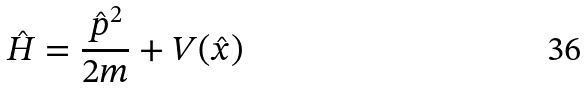<formula> <loc_0><loc_0><loc_500><loc_500>\hat { H } = \frac { \hat { p } ^ { 2 } } { 2 m } + V ( \hat { x } )</formula> 